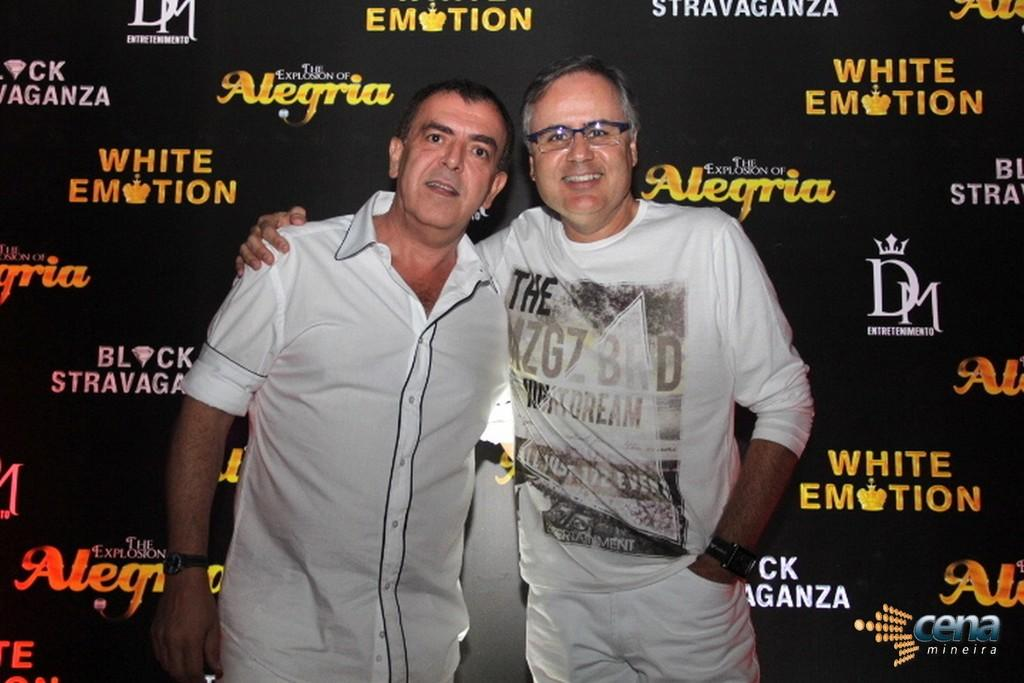Provide a one-sentence caption for the provided image. Two men stand next to each other smiling for the camera behind a wall showing sponsors such as White Emotion. 